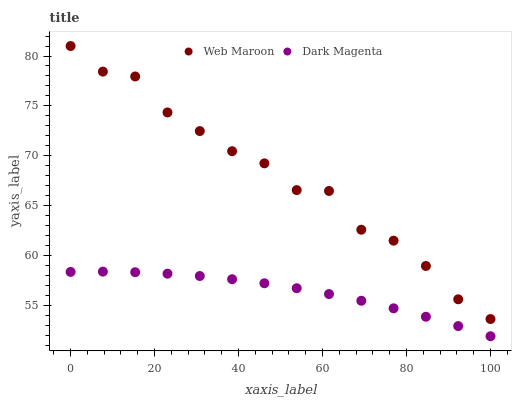Does Dark Magenta have the minimum area under the curve?
Answer yes or no. Yes. Does Web Maroon have the maximum area under the curve?
Answer yes or no. Yes. Does Dark Magenta have the maximum area under the curve?
Answer yes or no. No. Is Dark Magenta the smoothest?
Answer yes or no. Yes. Is Web Maroon the roughest?
Answer yes or no. Yes. Is Dark Magenta the roughest?
Answer yes or no. No. Does Dark Magenta have the lowest value?
Answer yes or no. Yes. Does Web Maroon have the highest value?
Answer yes or no. Yes. Does Dark Magenta have the highest value?
Answer yes or no. No. Is Dark Magenta less than Web Maroon?
Answer yes or no. Yes. Is Web Maroon greater than Dark Magenta?
Answer yes or no. Yes. Does Dark Magenta intersect Web Maroon?
Answer yes or no. No. 